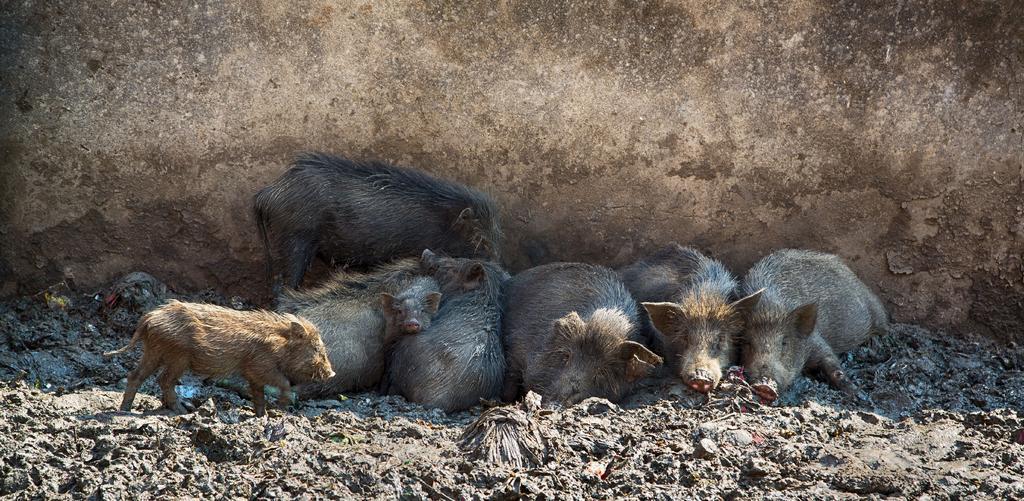How would you summarize this image in a sentence or two? There are many pigs on the ground. In the background there is a wall. 